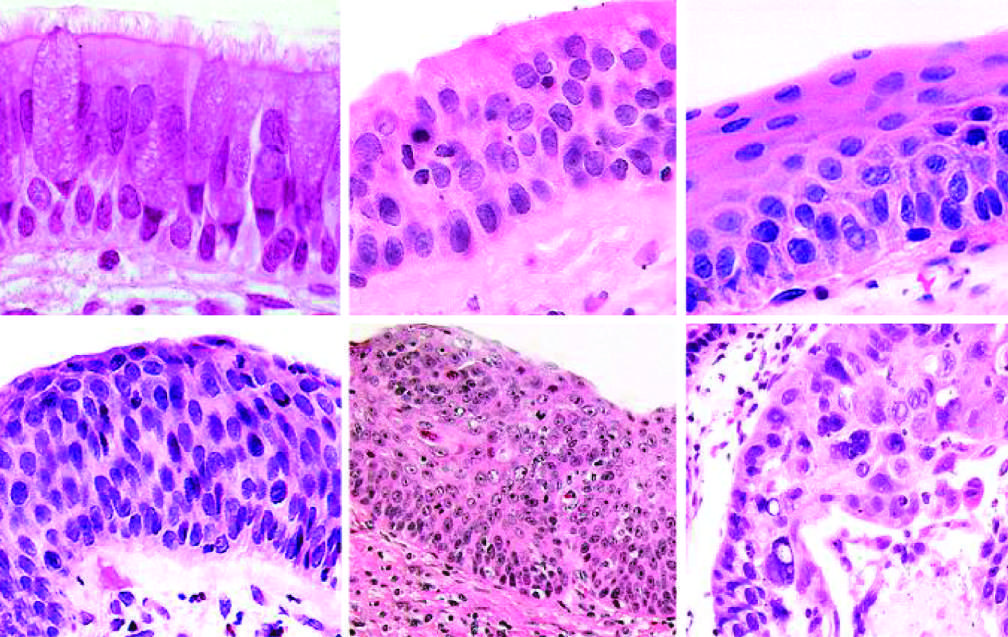what are similar to those in frank carcinoma, apart from the lack of basement membrane disruption in cis?
Answer the question using a single word or phrase. The cytologic features of cis 